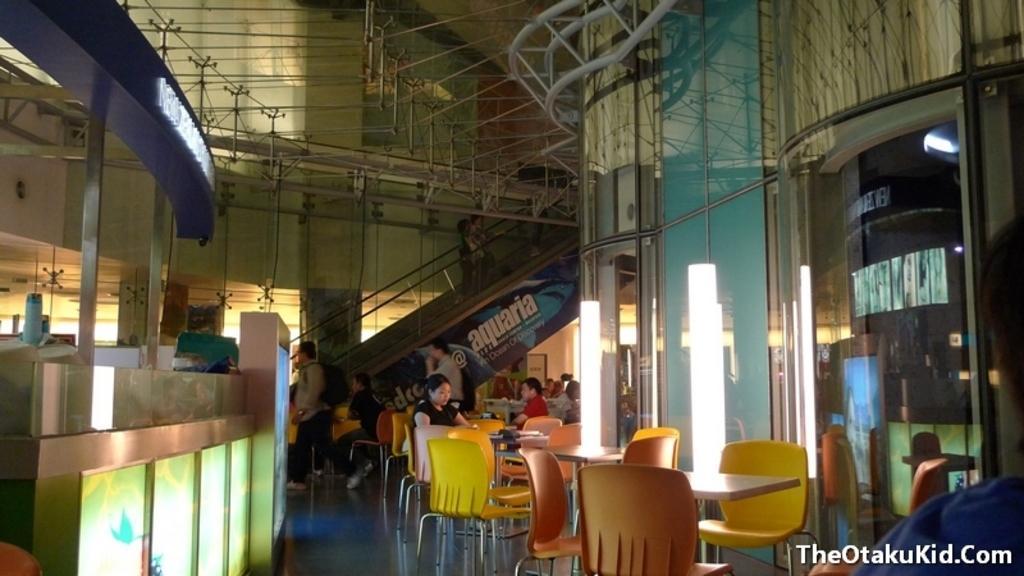Please provide a concise description of this image. In this picture there are people and we can see chairs, tables, boards, glass, rods, floor and objects. 